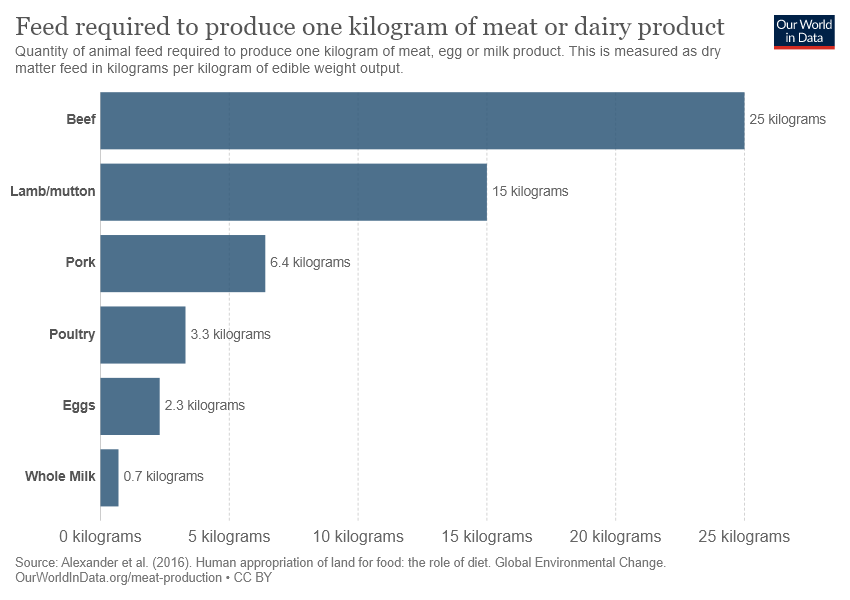Highlight a few significant elements in this photo. The value of the smallest bar is 0.7. It is not the case that the sum of the smallest three tow bars is equal to the third smallest bar. 